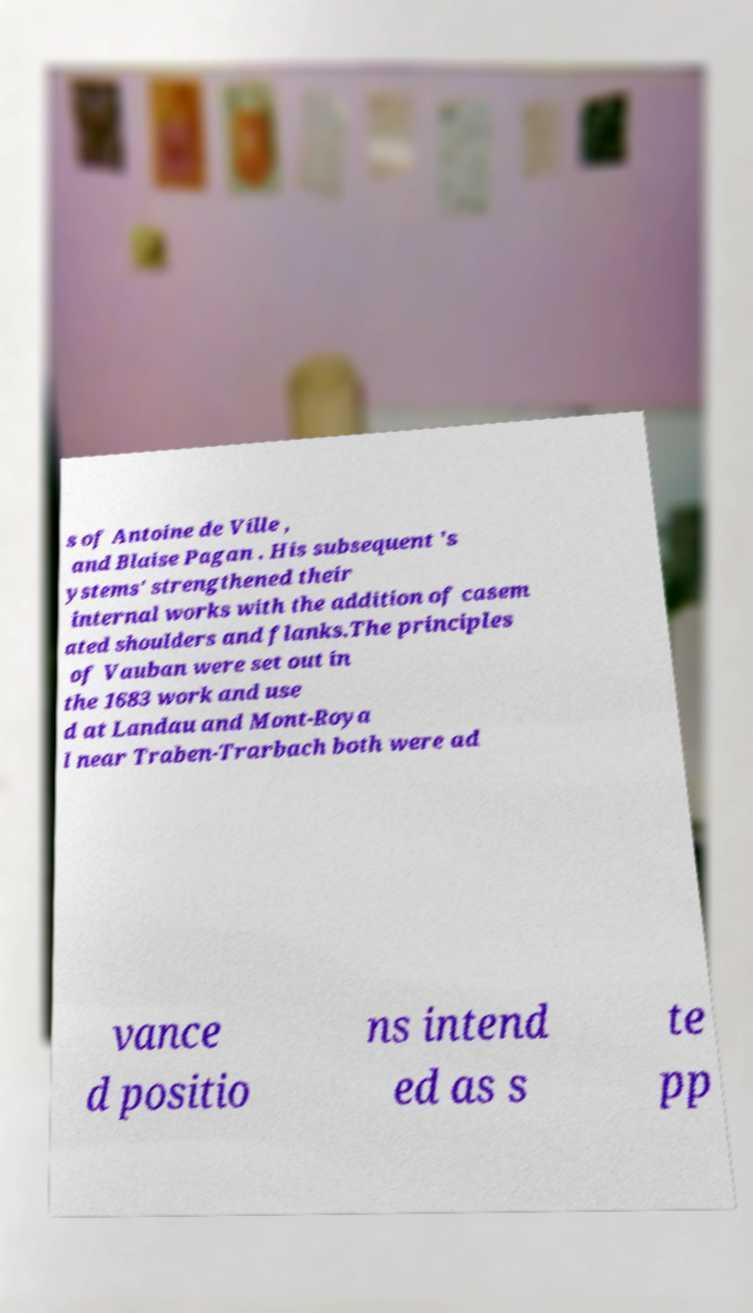Please identify and transcribe the text found in this image. s of Antoine de Ville , and Blaise Pagan . His subsequent 's ystems' strengthened their internal works with the addition of casem ated shoulders and flanks.The principles of Vauban were set out in the 1683 work and use d at Landau and Mont-Roya l near Traben-Trarbach both were ad vance d positio ns intend ed as s te pp 